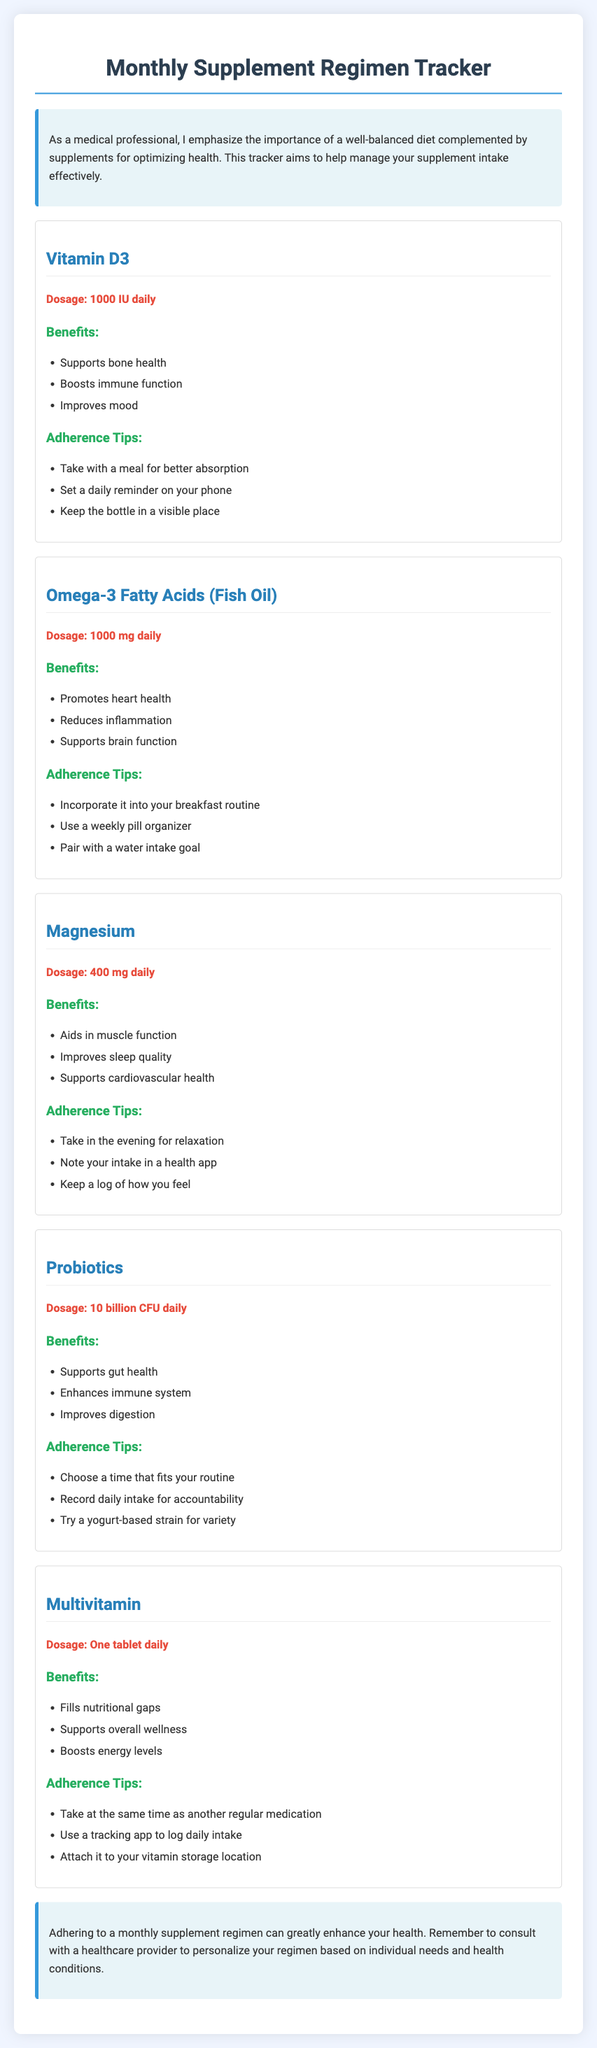What is the dosage of Vitamin D3? The document specifies that Vitamin D3 should be taken at a dosage of 1000 IU daily.
Answer: 1000 IU daily What are the benefits of Omega-3 Fatty Acids? The benefits listed for Omega-3 Fatty Acids include promoting heart health, reducing inflammation, and supporting brain function.
Answer: Promotes heart health, reduces inflammation, supports brain function What is the dosage of Magnesium? The document indicates that Magnesium should be taken at a dosage of 400 mg daily.
Answer: 400 mg daily Which supplement should be taken in the evening? According to the adherence tips for Magnesium, it should be taken in the evening for relaxation.
Answer: Magnesium What time of day is recommended for taking Probiotics? The document mentions that users should choose a time that fits their routine for taking Probiotics.
Answer: Any time that fits the routine How many billion CFU should be taken daily for Probiotics? The daily dosage for Probiotics in the document is specified as 10 billion CFU.
Answer: 10 billion CFU What should be paired with Omega-3 intake for adherence? The adherence tips recommend pairing Omega-3 intake with a water intake goal.
Answer: A water intake goal What is the primary function of a multivitamin as mentioned in the document? The primary function is to fill nutritional gaps as stated in the benefits section for the multivitamin.
Answer: Fills nutritional gaps What health aspect does Vitamin D3 support? The document states that Vitamin D3 supports bone health.
Answer: Bone health 